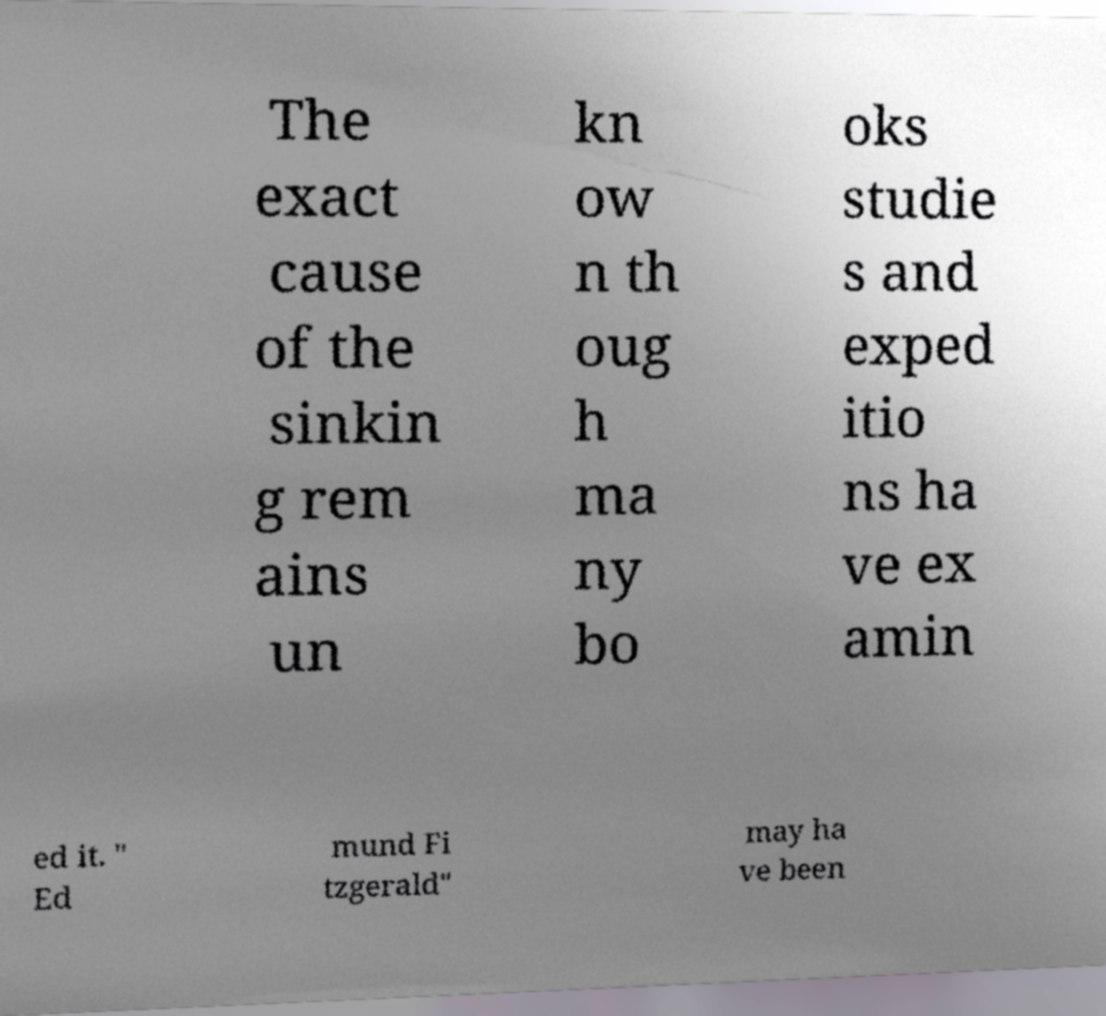There's text embedded in this image that I need extracted. Can you transcribe it verbatim? The exact cause of the sinkin g rem ains un kn ow n th oug h ma ny bo oks studie s and exped itio ns ha ve ex amin ed it. " Ed mund Fi tzgerald" may ha ve been 